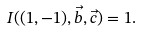Convert formula to latex. <formula><loc_0><loc_0><loc_500><loc_500>I ( ( 1 , - 1 ) , \vec { b } , \vec { c } ) = 1 .</formula> 